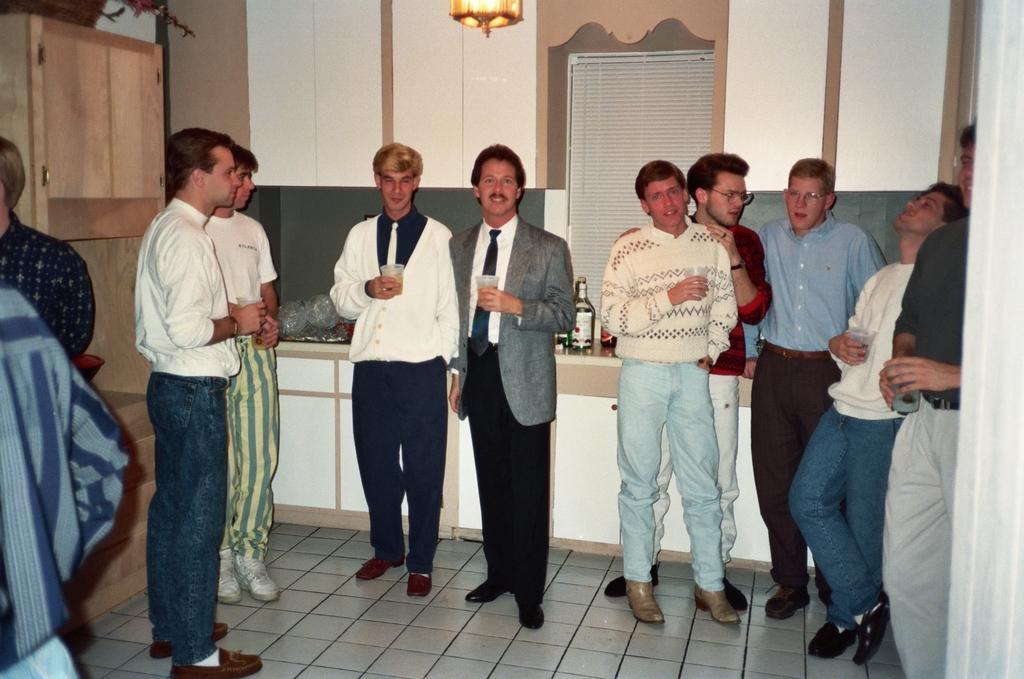How would you summarize this image in a sentence or two? In this picture we can see a group of people standing and some people holding the glasses. Behind the people there are glasses and bottles on the platform and a wall. At the top there is a light and on the left side of the people there is a wooden object. 